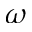Convert formula to latex. <formula><loc_0><loc_0><loc_500><loc_500>\omega</formula> 